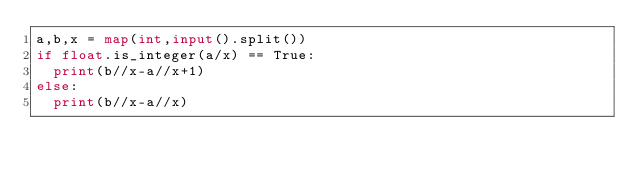<code> <loc_0><loc_0><loc_500><loc_500><_Python_>a,b,x = map(int,input().split())
if float.is_integer(a/x) == True:
  print(b//x-a//x+1)
else:
  print(b//x-a//x)</code> 